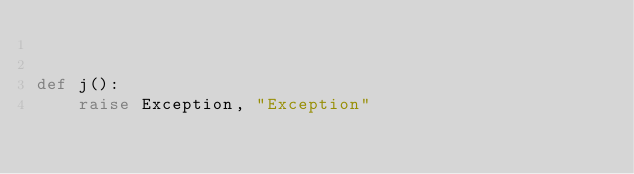<code> <loc_0><loc_0><loc_500><loc_500><_Python_>

def j():
    raise Exception, "Exception"
</code> 